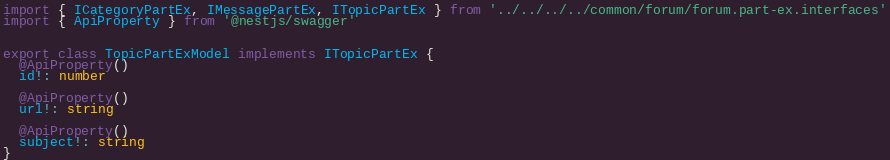Convert code to text. <code><loc_0><loc_0><loc_500><loc_500><_TypeScript_>import { ICategoryPartEx, IMessagePartEx, ITopicPartEx } from '../../../../common/forum/forum.part-ex.interfaces'
import { ApiProperty } from '@nestjs/swagger'


export class TopicPartExModel implements ITopicPartEx {
  @ApiProperty()
  id!: number

  @ApiProperty()
  url!: string

  @ApiProperty()
  subject!: string
}
</code> 